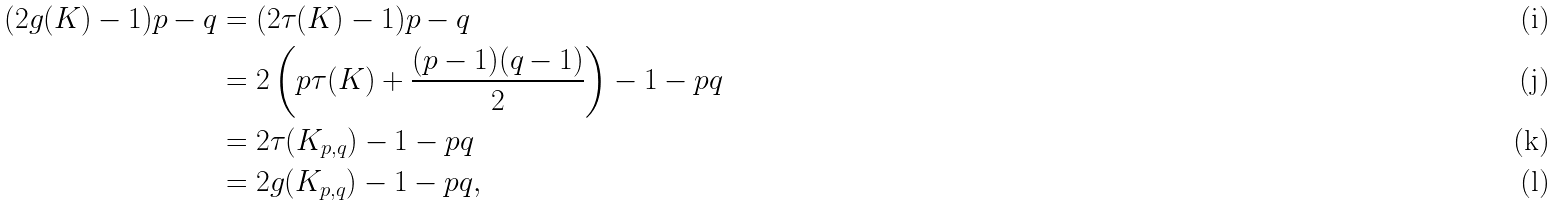Convert formula to latex. <formula><loc_0><loc_0><loc_500><loc_500>( 2 g ( K ) - 1 ) p - q & = ( 2 \tau ( K ) - 1 ) p - q \\ & = 2 \left ( p \tau ( K ) + \frac { ( p - 1 ) ( q - 1 ) } { 2 } \right ) - 1 - p q \\ & = 2 \tau ( K _ { p , q } ) - 1 - p q \\ & = 2 g ( K _ { p , q } ) - 1 - p q ,</formula> 